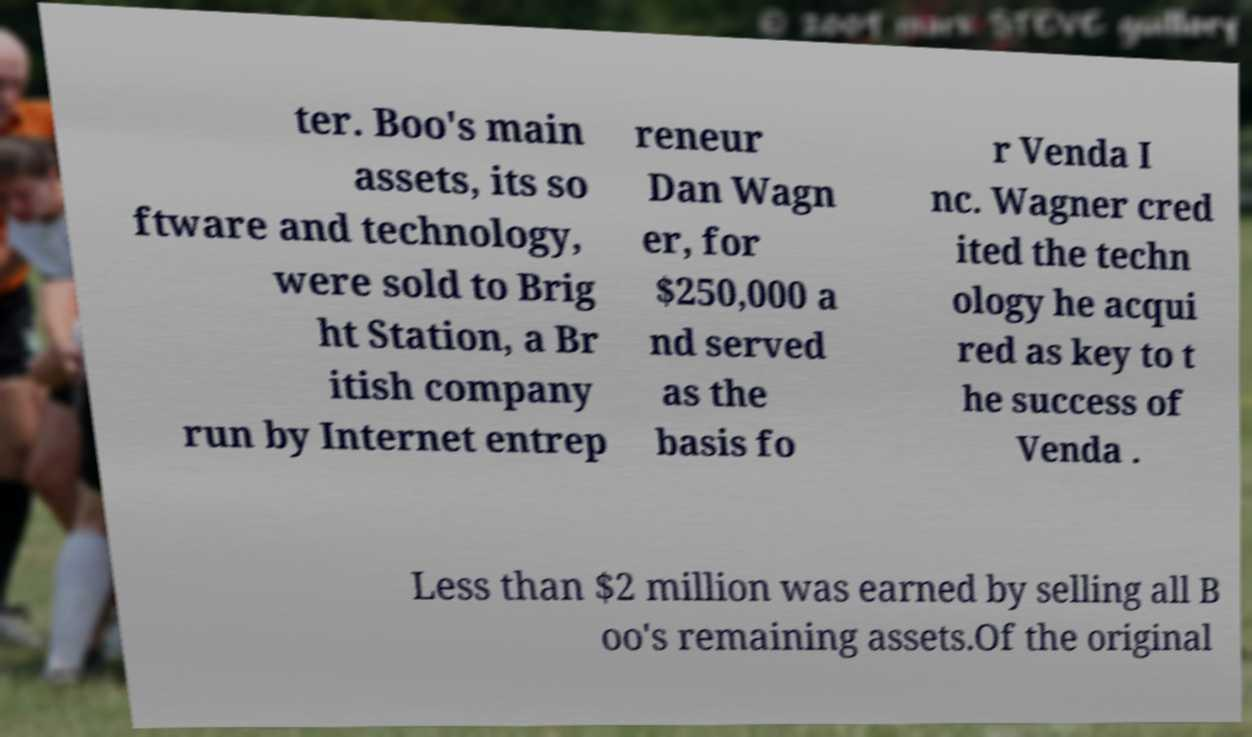Can you read and provide the text displayed in the image?This photo seems to have some interesting text. Can you extract and type it out for me? ter. Boo's main assets, its so ftware and technology, were sold to Brig ht Station, a Br itish company run by Internet entrep reneur Dan Wagn er, for $250,000 a nd served as the basis fo r Venda I nc. Wagner cred ited the techn ology he acqui red as key to t he success of Venda . Less than $2 million was earned by selling all B oo's remaining assets.Of the original 